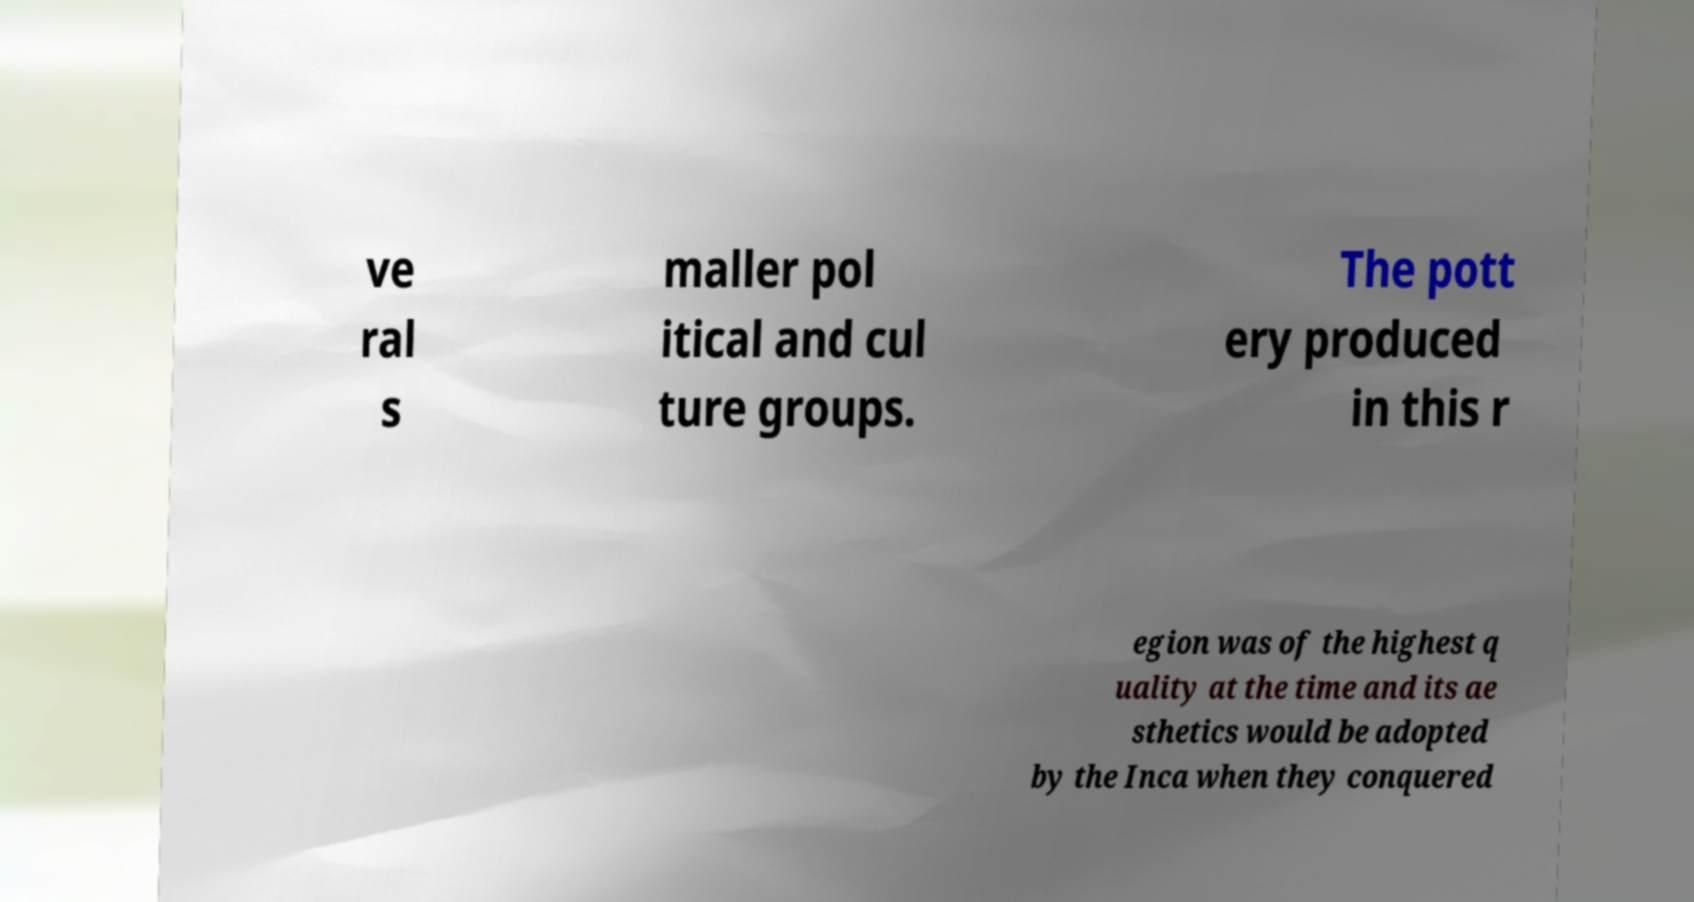Please identify and transcribe the text found in this image. ve ral s maller pol itical and cul ture groups. The pott ery produced in this r egion was of the highest q uality at the time and its ae sthetics would be adopted by the Inca when they conquered 